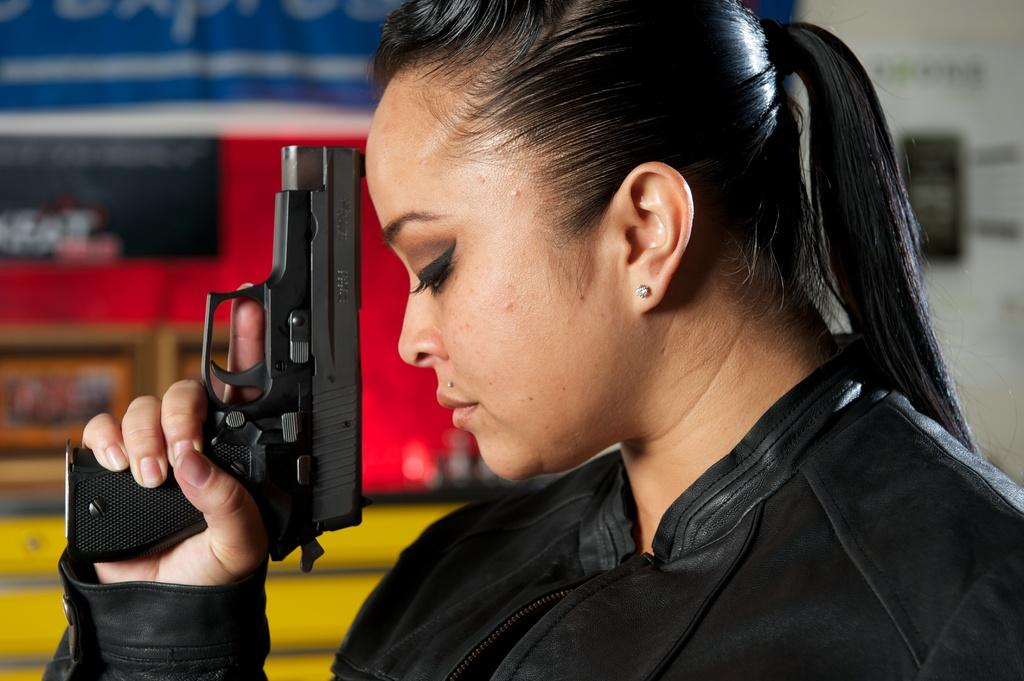Who is present in the image? There is a woman in the image. What is the woman holding in her hand? The woman is holding a gun in her hand. Can you describe the objects in the background of the image? The objects in the background have blue, red, yellow, and white colors. What is the purpose of the trousers in the image? There are no trousers present in the image, so it is not possible to determine their purpose. 